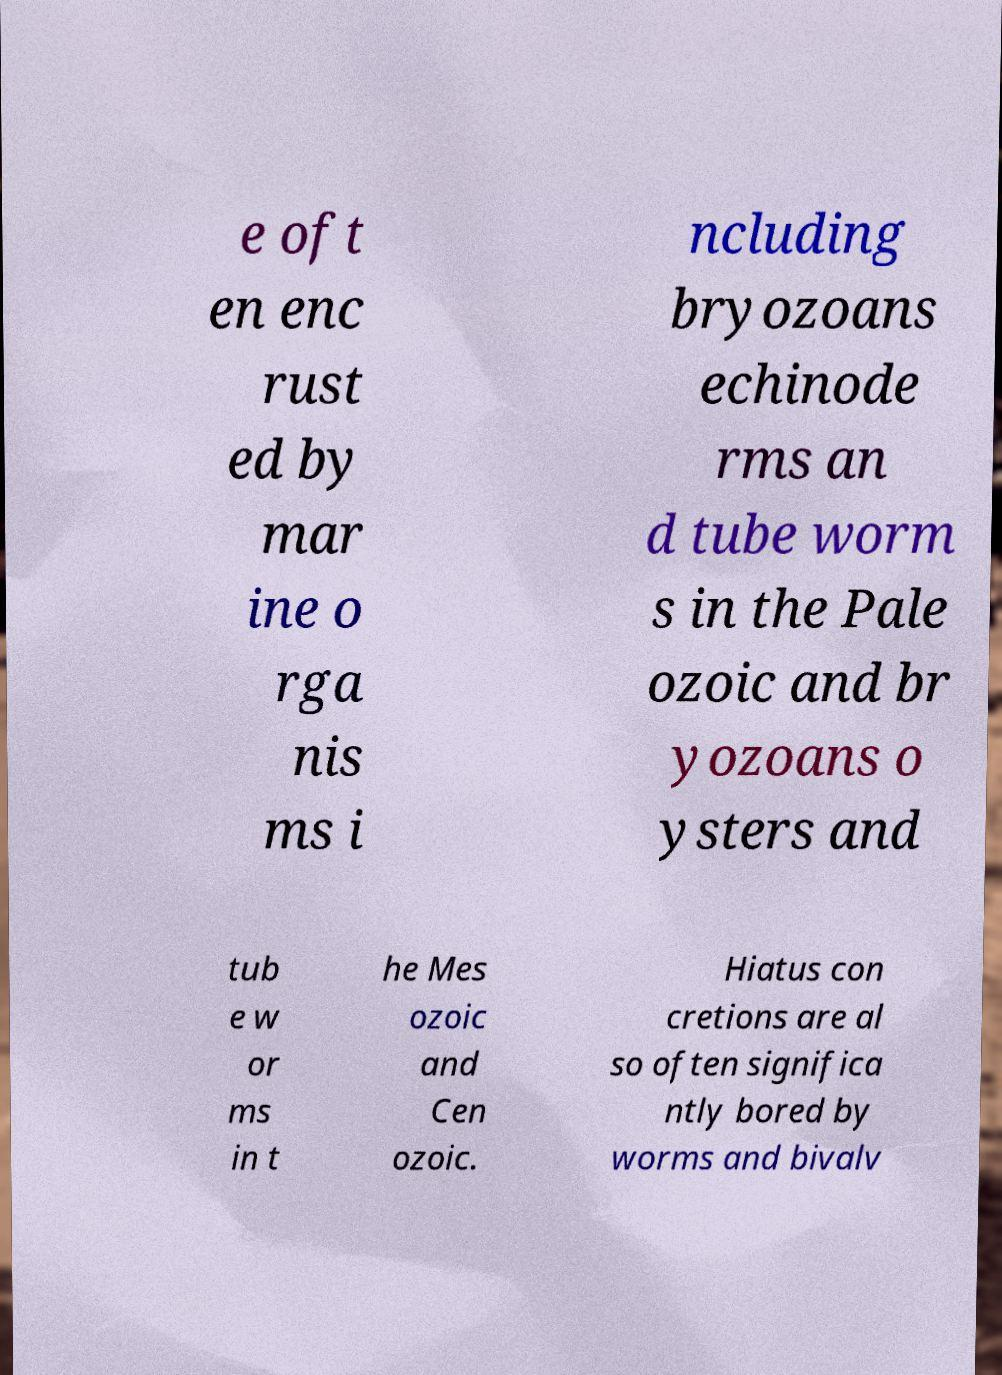Please read and relay the text visible in this image. What does it say? e oft en enc rust ed by mar ine o rga nis ms i ncluding bryozoans echinode rms an d tube worm s in the Pale ozoic and br yozoans o ysters and tub e w or ms in t he Mes ozoic and Cen ozoic. Hiatus con cretions are al so often significa ntly bored by worms and bivalv 